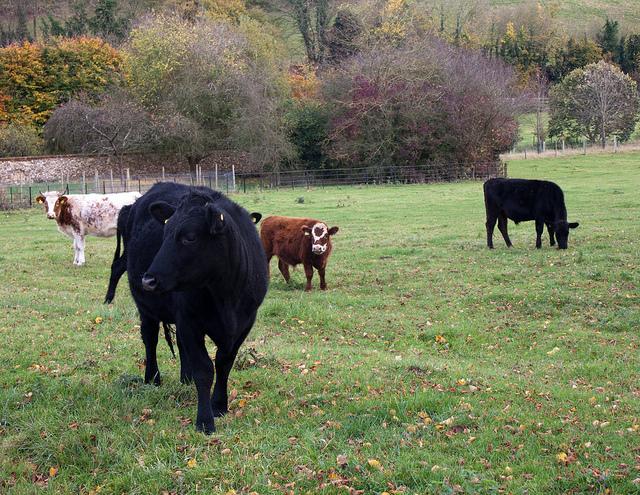What many black cows are there?
Quick response, please. 2. How many people are there?
Be succinct. 0. How many animals are there?
Short answer required. 4. How many cattle are on the field?
Concise answer only. 4. 